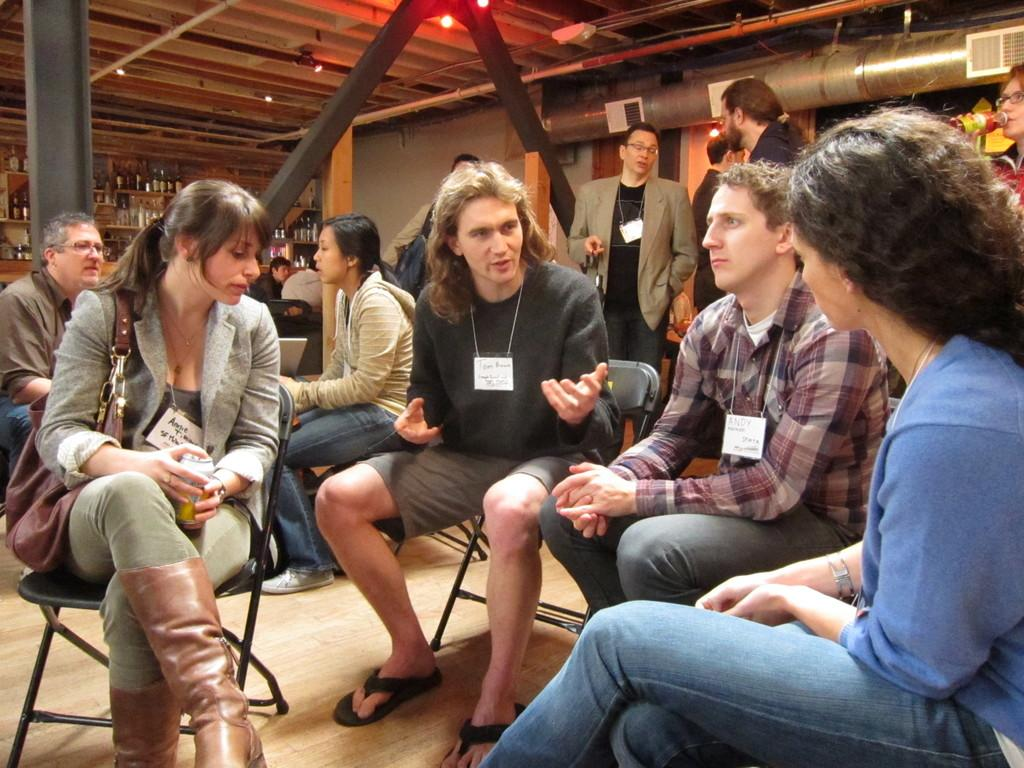How many persons can be seen sitting on chairs in the image? There are many persons sitting on chairs in the image. What can be seen in the background of the image? In the background of the image, there are persons, bottles, shelves, pipes, an air conditioner, and a wall. What direction is the cook facing in the image? There is no cook present in the image. What type of answer is being given by the person in the image? There is no person giving an answer in the image. 